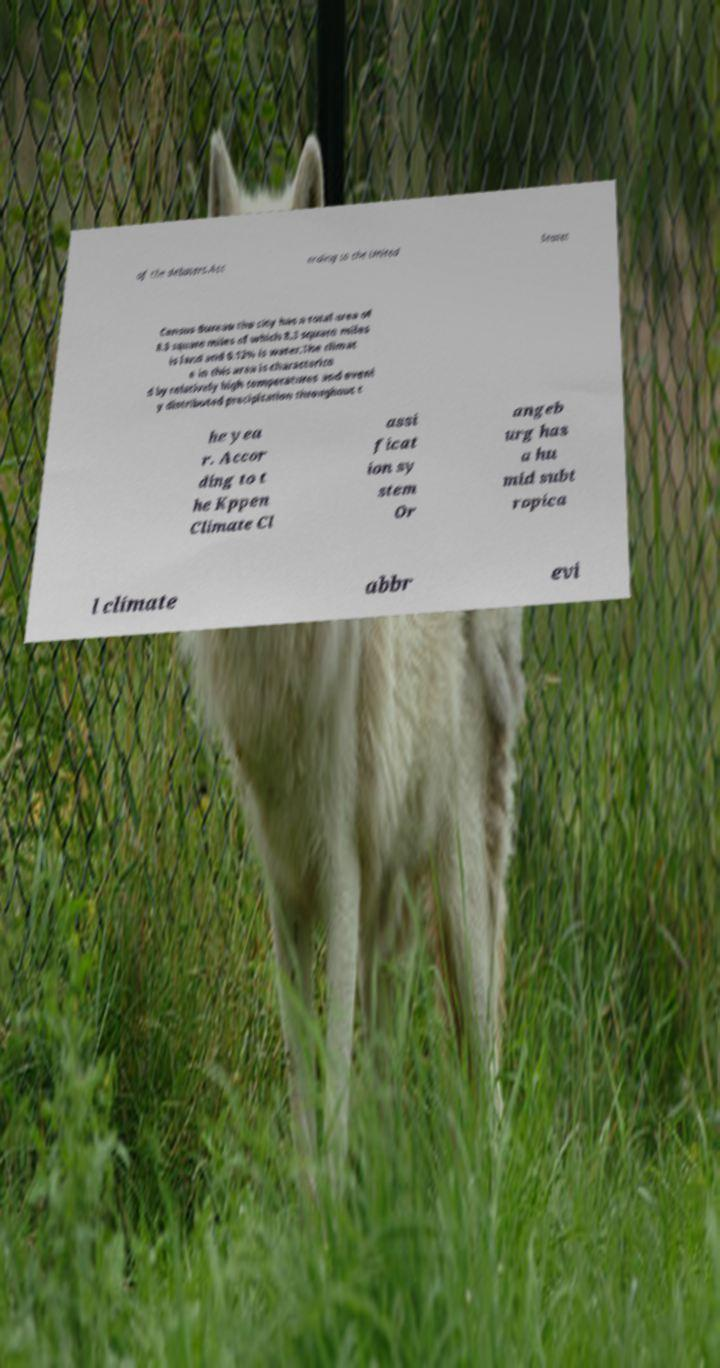Please read and relay the text visible in this image. What does it say? of the debaters.Acc ording to the United States Census Bureau the city has a total area of 8.3 square miles of which 8.3 square miles is land and 0.12% is water.The climat e in this area is characterize d by relatively high temperatures and evenl y distributed precipitation throughout t he yea r. Accor ding to t he Kppen Climate Cl assi ficat ion sy stem Or angeb urg has a hu mid subt ropica l climate abbr evi 